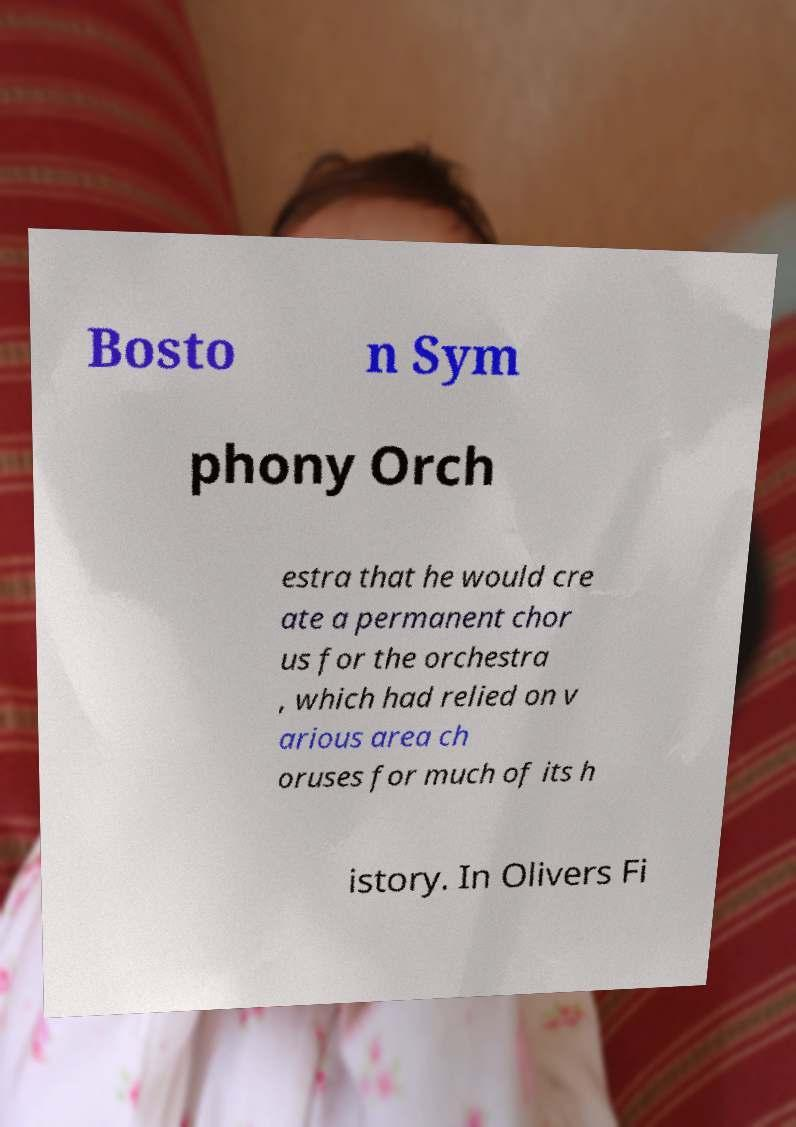Please read and relay the text visible in this image. What does it say? Bosto n Sym phony Orch estra that he would cre ate a permanent chor us for the orchestra , which had relied on v arious area ch oruses for much of its h istory. In Olivers Fi 